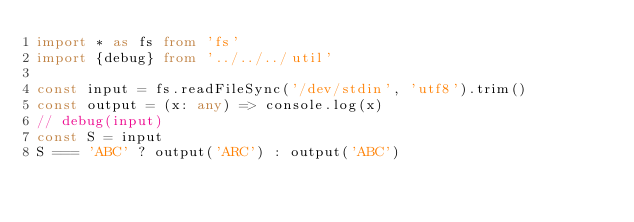Convert code to text. <code><loc_0><loc_0><loc_500><loc_500><_TypeScript_>import * as fs from 'fs'
import {debug} from '../../../util'

const input = fs.readFileSync('/dev/stdin', 'utf8').trim()
const output = (x: any) => console.log(x)
// debug(input)
const S = input
S === 'ABC' ? output('ARC') : output('ABC')</code> 